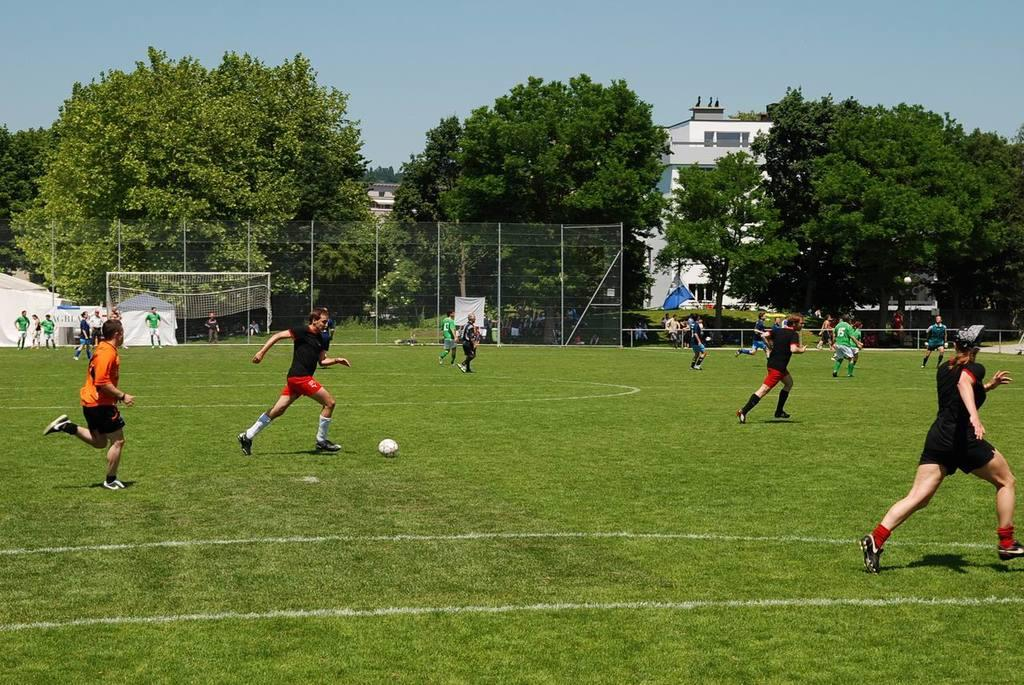What activity are the people in the image engaged in? The people in the image are playing football. What can be seen in the background of the image? In the background of the image, there is a net, a fence, trees, buildings, and the sky. How many distinct elements can be identified in the background of the image? There are five distinct elements in the background of the image: a net, a fence, trees, buildings, and the sky. What is the reason for the amount of corn being harvested in the image? There is no corn present in the image, so it is not possible to determine the reason for any harvesting. 